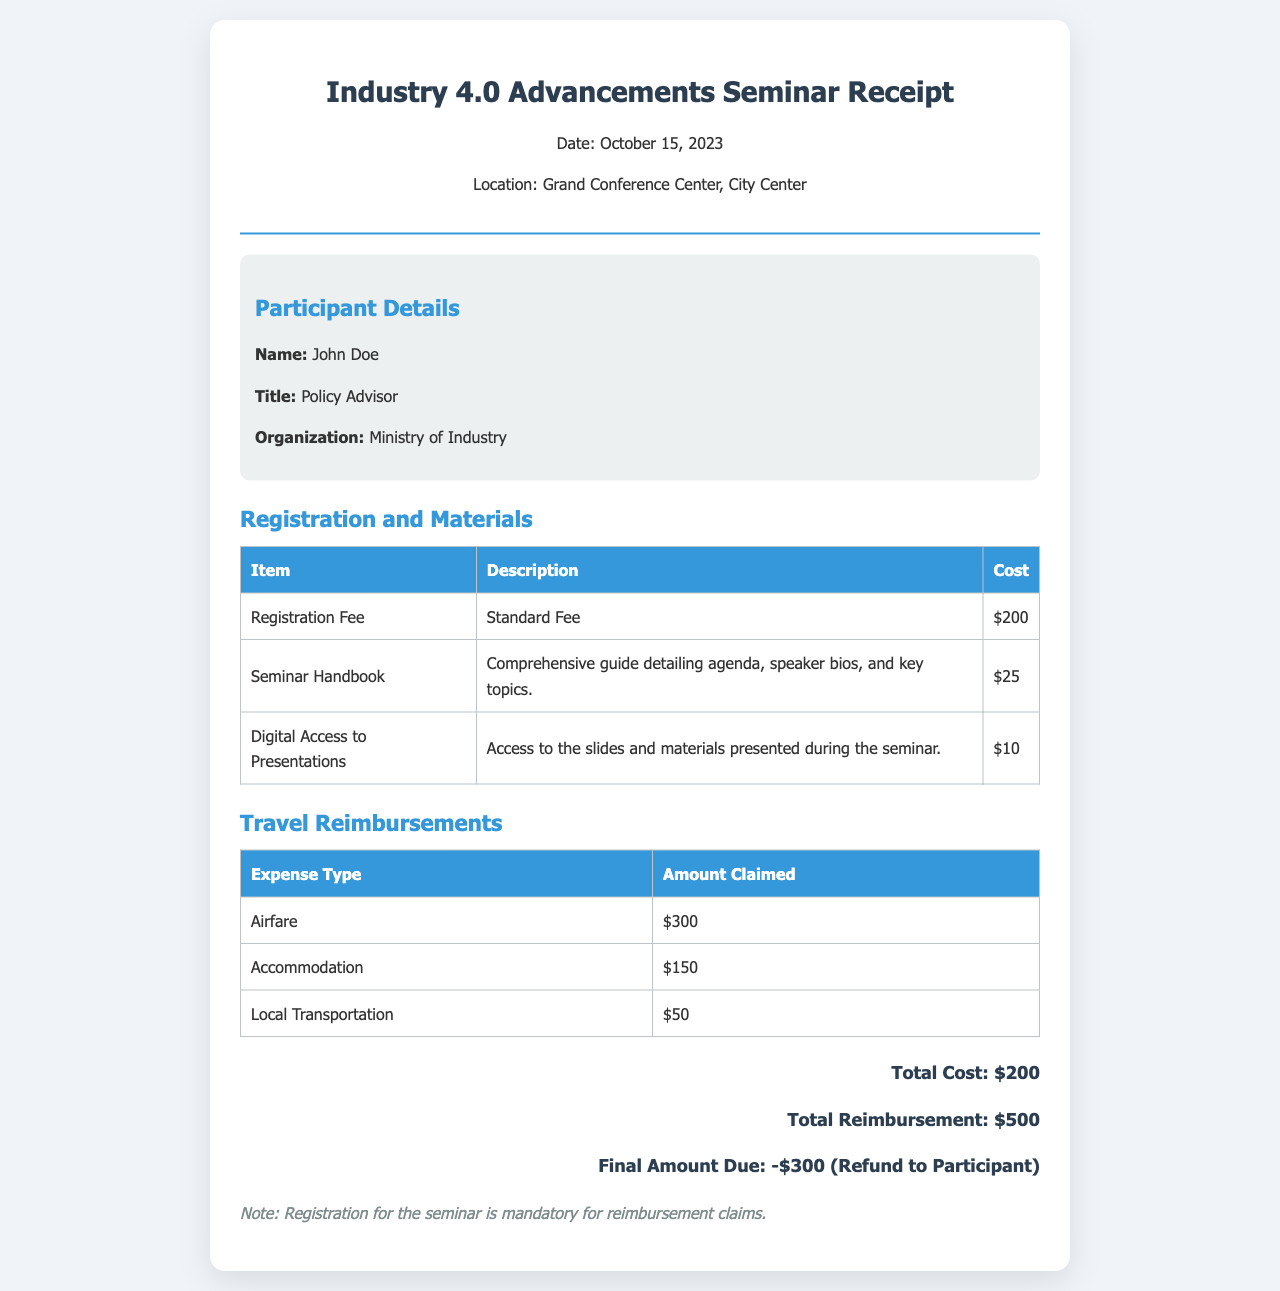What is the date of the seminar? The date of the seminar is mentioned in the header of the receipt.
Answer: October 15, 2023 What is the location of the seminar? The location is specified in the header section of the document.
Answer: Grand Conference Center, City Center What was the registration fee? The registration fee is listed in the costs table under Registration and Materials.
Answer: $200 How much was claimed for airfare? The airfare amount is found in the Travel Reimbursements section of the document.
Answer: $300 What is the total reimbursement amount? The total reimbursement is calculated by summing the amounts in the Travel Reimbursements table.
Answer: $500 What is the total cost listed in the document? The total cost is detailed at the bottom of the receipt.
Answer: $200 What is the final amount due? The final amount due is calculated as the difference between the total cost and the total reimbursement stated in the document.
Answer: -$300 (Refund to Participant) What materials were provided to the participants? The materials offered are listed in the costs table under Registration and Materials.
Answer: Seminar Handbook, Digital Access to Presentations Why is registration mandatory for reimbursement claims? This note is provided at the end of the receipt providing clarity on reimbursement policy.
Answer: Registration for the seminar is mandatory for reimbursement claims 